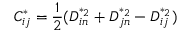<formula> <loc_0><loc_0><loc_500><loc_500>C _ { i j } ^ { * } = \frac { 1 } { 2 } ( D _ { i n } ^ { * _ { 2 } } + D _ { j n } ^ { * _ { 2 } } - D _ { i j } ^ { * _ { 2 } } )</formula> 